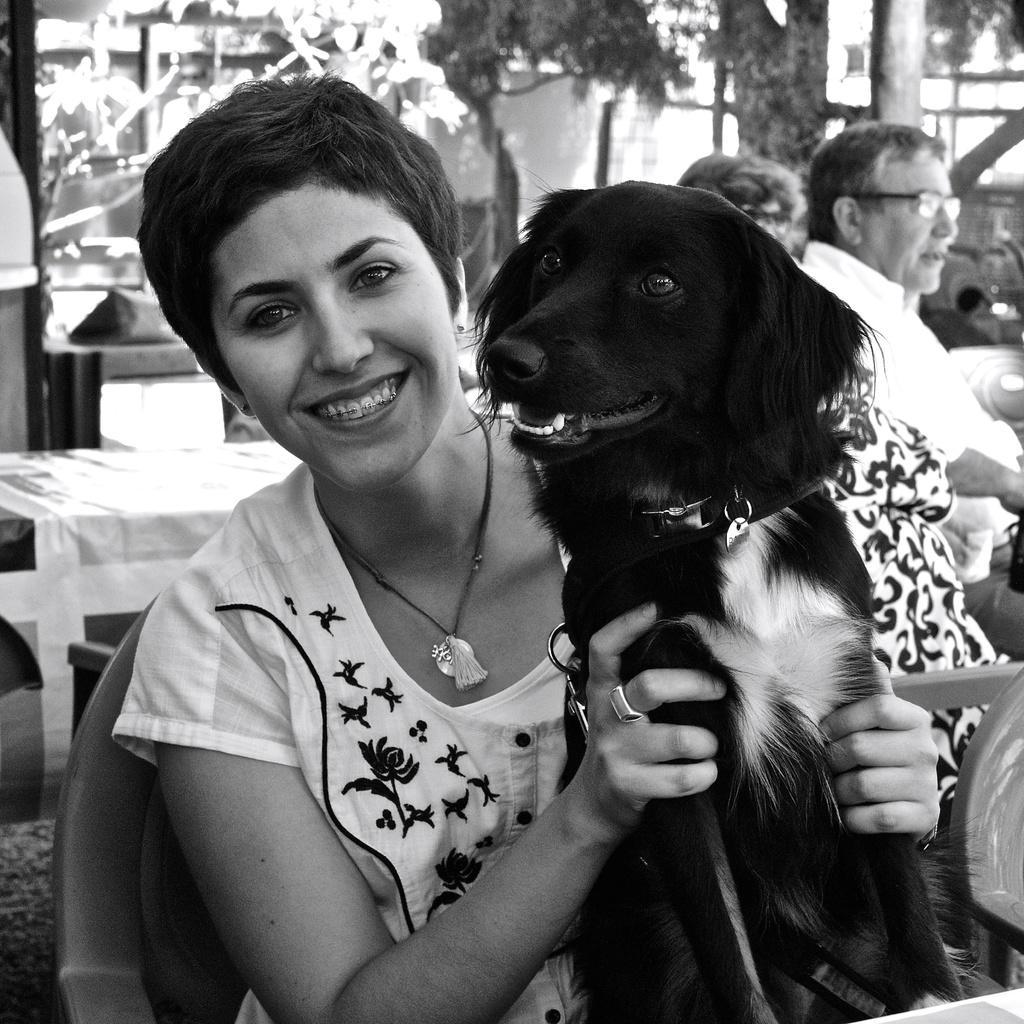Please provide a concise description of this image. There is a woman, smiling, sitting in the chair. She's holding a dog in her hands which is black in color. In the background, there are some people sitting. We can observe some trees here. 